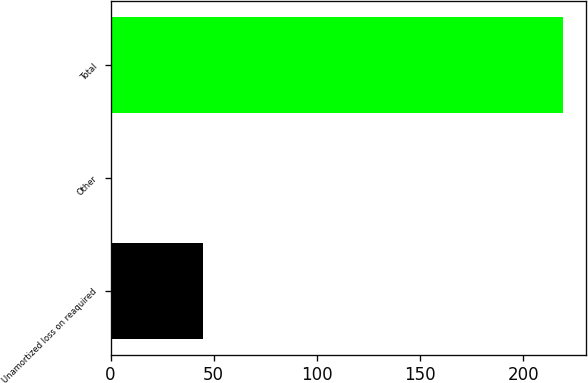<chart> <loc_0><loc_0><loc_500><loc_500><bar_chart><fcel>Unamortized loss on reaquired<fcel>Other<fcel>Total<nl><fcel>45<fcel>0.3<fcel>219.4<nl></chart> 